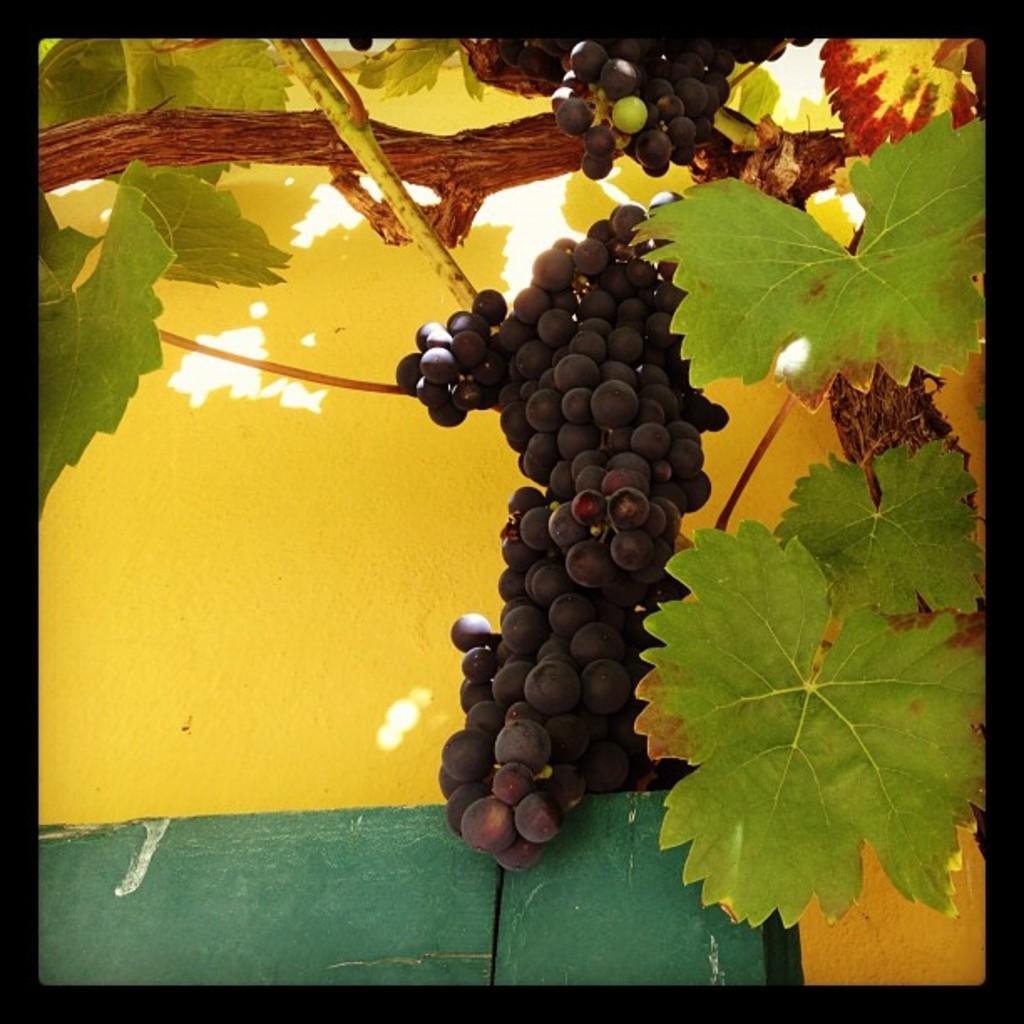In one or two sentences, can you explain what this image depicts? In this image there is a grape tree. In the tree there are grapes. In the background there is yellow wall. 